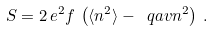Convert formula to latex. <formula><loc_0><loc_0><loc_500><loc_500>S = 2 \, e ^ { 2 } f \, \left ( \langle { n ^ { 2 } } \rangle - \ q a v { n } ^ { 2 } \right ) \, .</formula> 